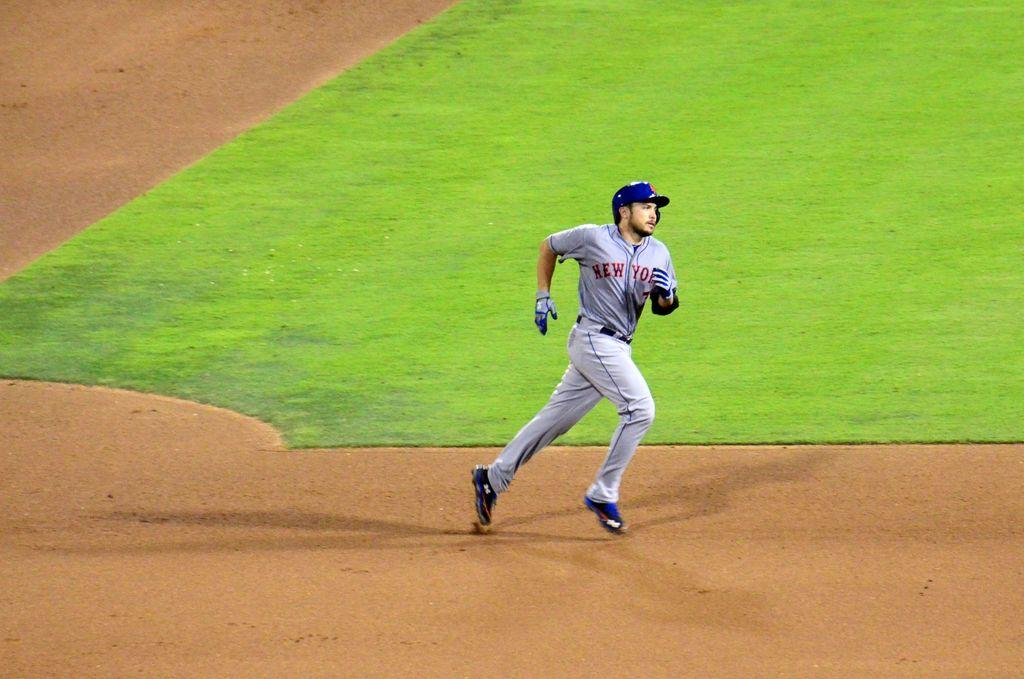Provide a one-sentence caption for the provided image. The person running is on the team from New York. 